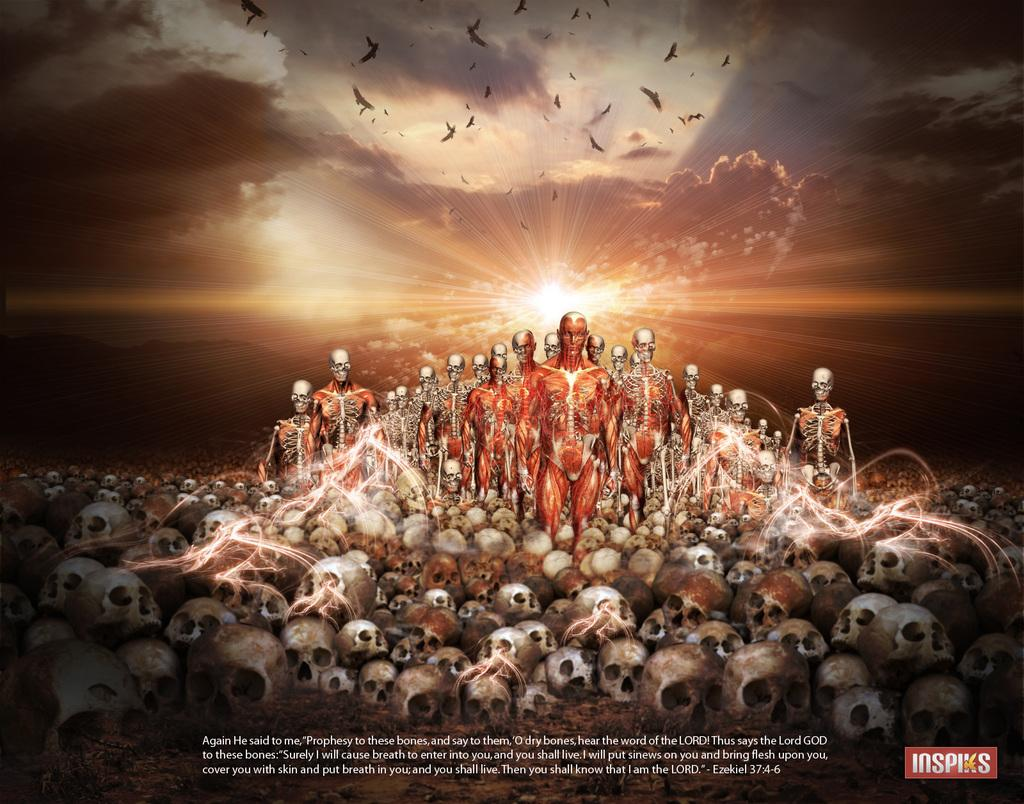<image>
Share a concise interpretation of the image provided. A sci fi poster with a quote done by Inspiks. 